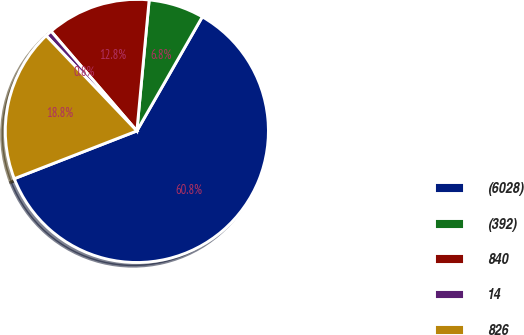Convert chart. <chart><loc_0><loc_0><loc_500><loc_500><pie_chart><fcel>(6028)<fcel>(392)<fcel>840<fcel>14<fcel>826<nl><fcel>60.81%<fcel>6.8%<fcel>12.8%<fcel>0.8%<fcel>18.8%<nl></chart> 